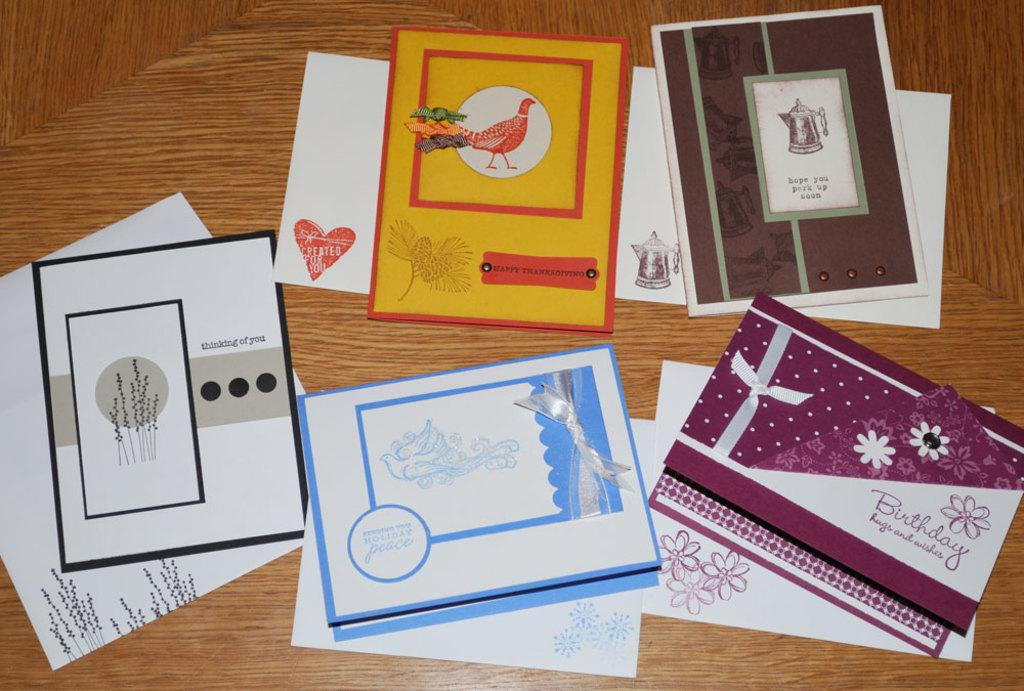<image>
Provide a brief description of the given image. the word birthday is on the front of the card 